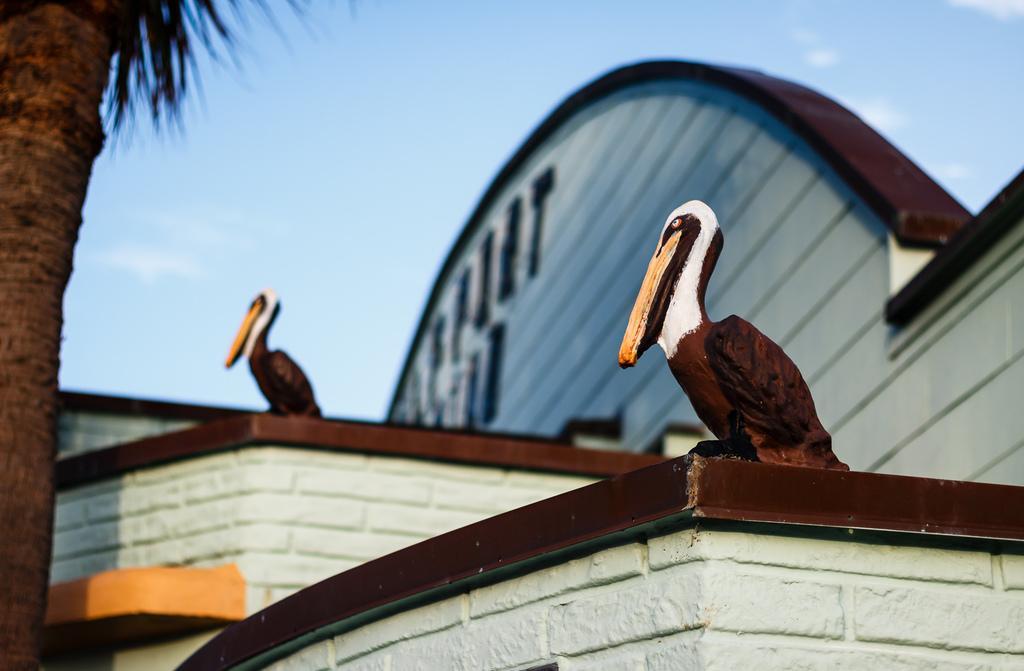In one or two sentences, can you explain what this image depicts? In this picture I can see two sculptures of birds on the building, there is a tree, and in the background there is the sky. 